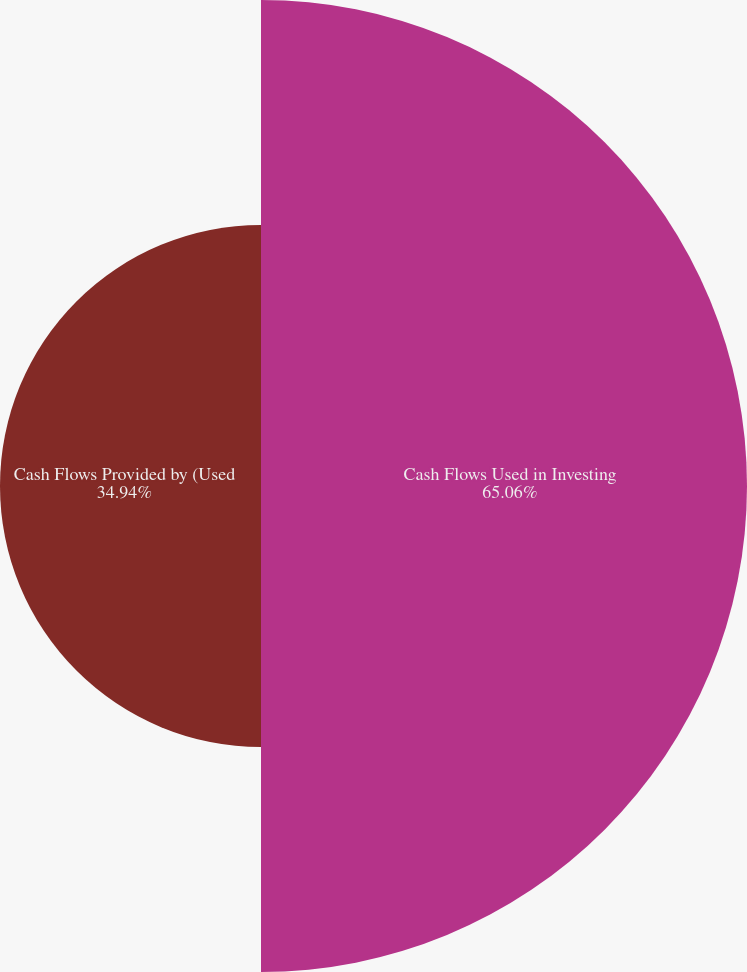Convert chart to OTSL. <chart><loc_0><loc_0><loc_500><loc_500><pie_chart><fcel>Cash Flows Used in Investing<fcel>Cash Flows Provided by (Used<nl><fcel>65.06%<fcel>34.94%<nl></chart> 